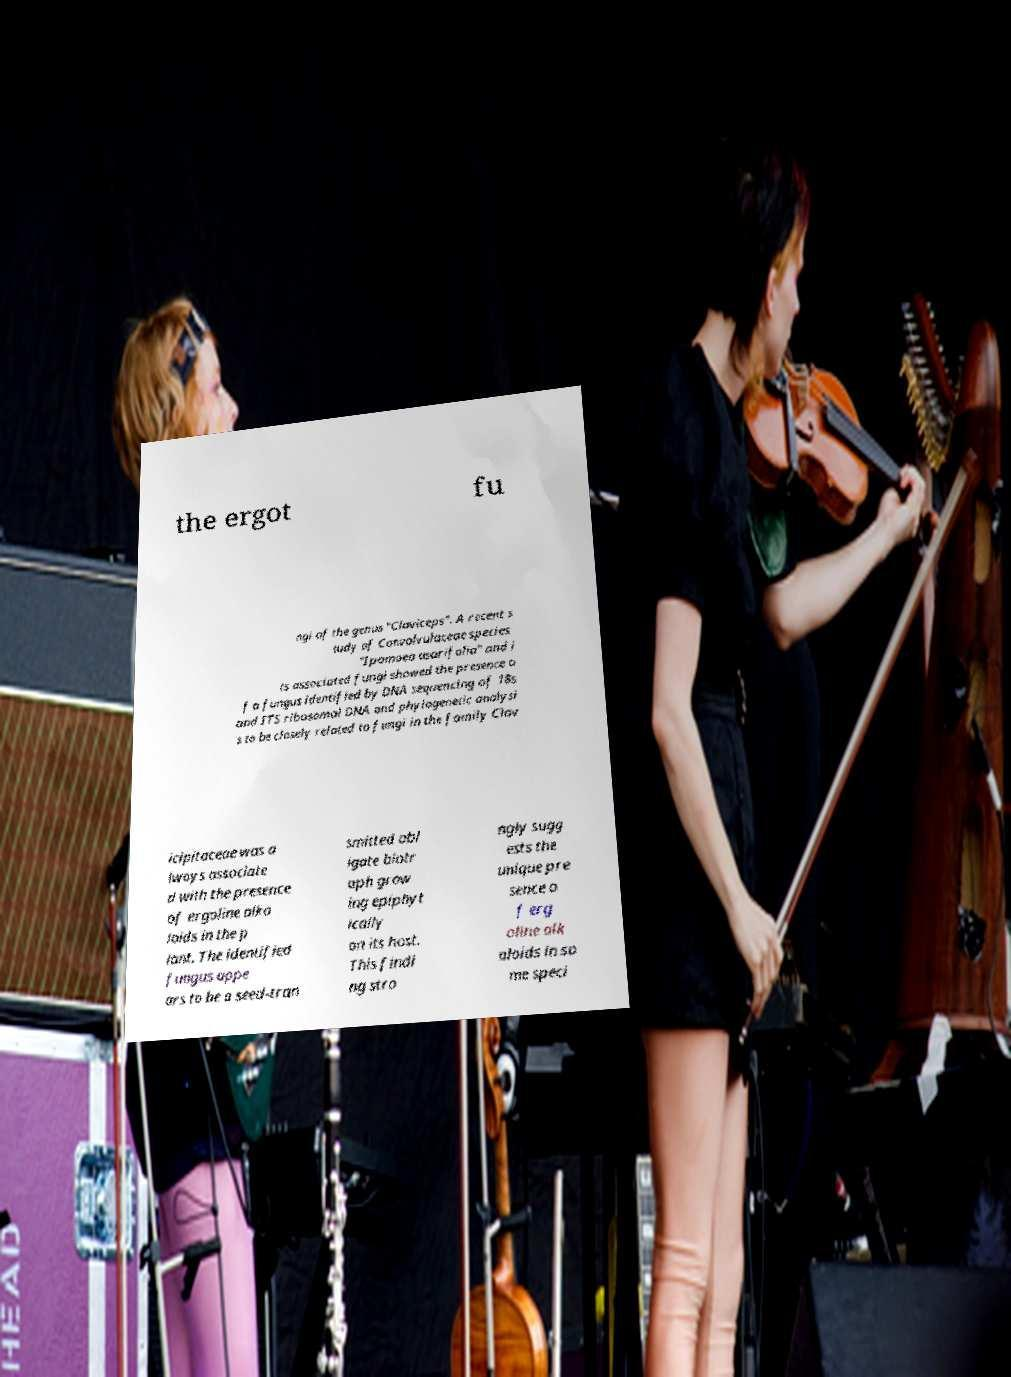What messages or text are displayed in this image? I need them in a readable, typed format. the ergot fu ngi of the genus "Claviceps". A recent s tudy of Convolvulaceae species "Ipomoea asarifolia" and i ts associated fungi showed the presence o f a fungus identified by DNA sequencing of 18s and ITS ribosomal DNA and phylogenetic analysi s to be closely related to fungi in the family Clav icipitaceae was a lways associate d with the presence of ergoline alka loids in the p lant. The identified fungus appe ars to be a seed-tran smitted obl igate biotr oph grow ing epiphyt ically on its host. This findi ng stro ngly sugg ests the unique pre sence o f erg oline alk aloids in so me speci 